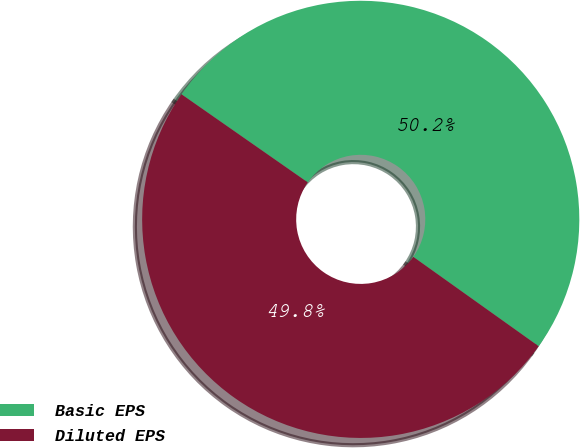<chart> <loc_0><loc_0><loc_500><loc_500><pie_chart><fcel>Basic EPS<fcel>Diluted EPS<nl><fcel>50.16%<fcel>49.84%<nl></chart> 